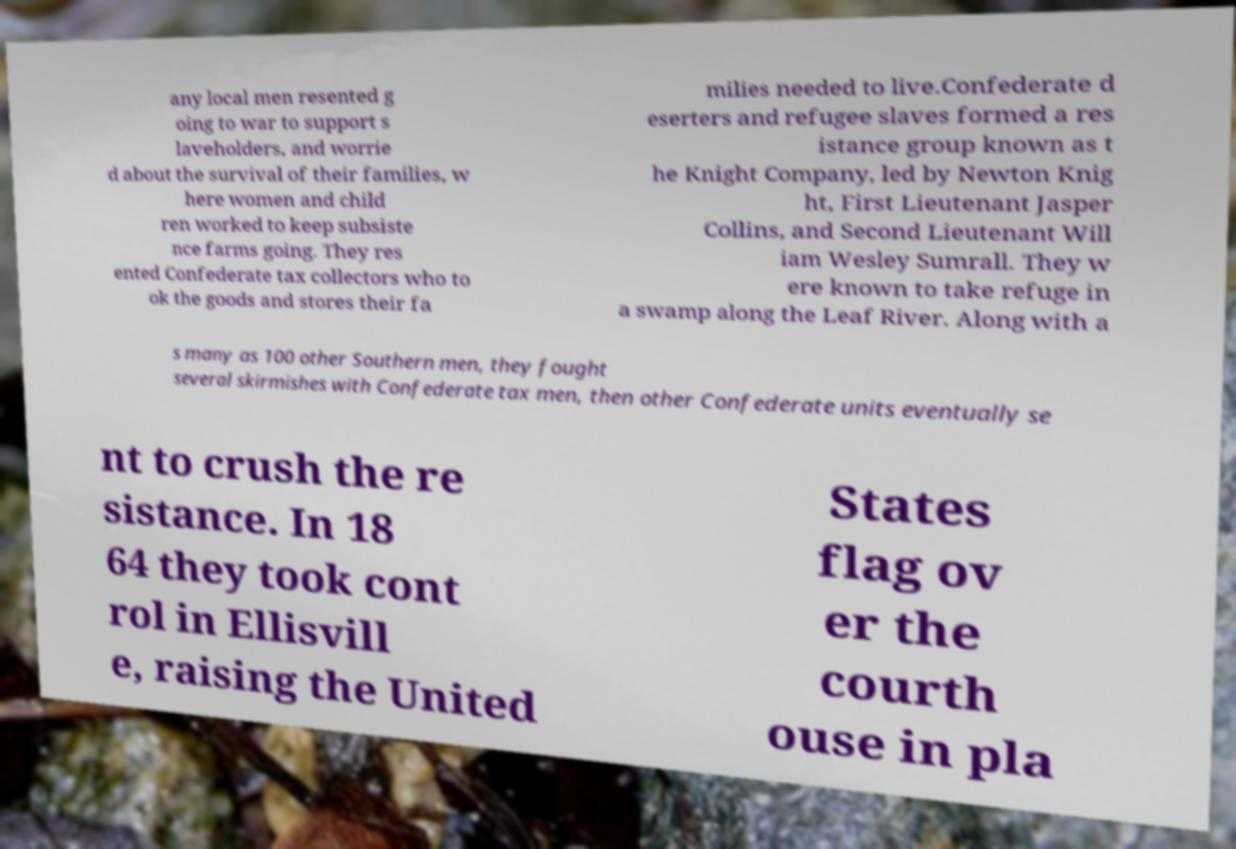I need the written content from this picture converted into text. Can you do that? any local men resented g oing to war to support s laveholders, and worrie d about the survival of their families, w here women and child ren worked to keep subsiste nce farms going. They res ented Confederate tax collectors who to ok the goods and stores their fa milies needed to live.Confederate d eserters and refugee slaves formed a res istance group known as t he Knight Company, led by Newton Knig ht, First Lieutenant Jasper Collins, and Second Lieutenant Will iam Wesley Sumrall. They w ere known to take refuge in a swamp along the Leaf River. Along with a s many as 100 other Southern men, they fought several skirmishes with Confederate tax men, then other Confederate units eventually se nt to crush the re sistance. In 18 64 they took cont rol in Ellisvill e, raising the United States flag ov er the courth ouse in pla 